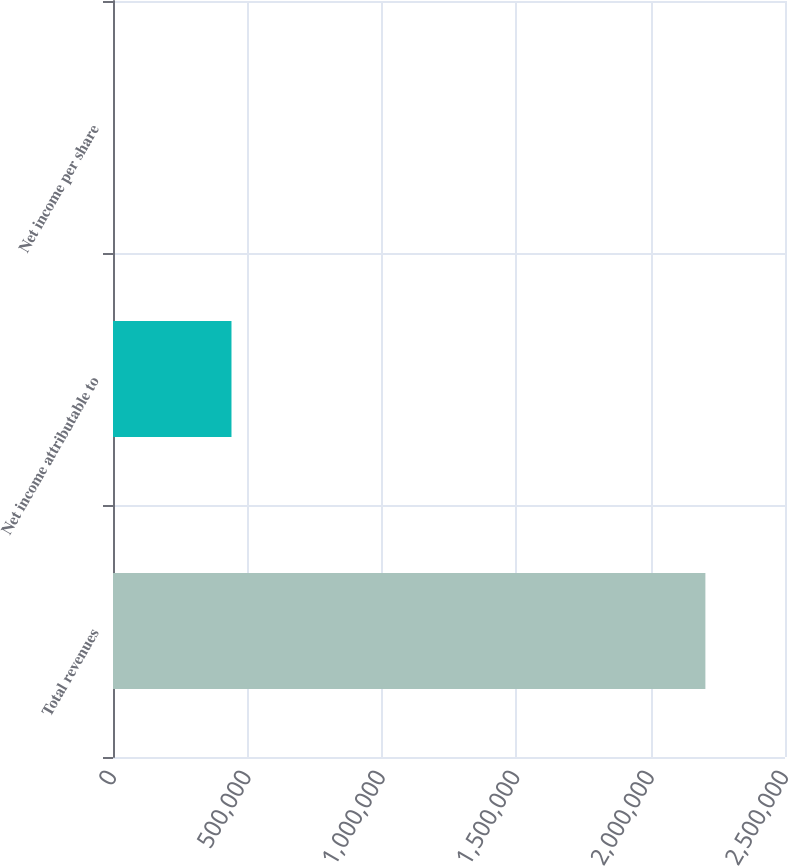Convert chart to OTSL. <chart><loc_0><loc_0><loc_500><loc_500><bar_chart><fcel>Total revenues<fcel>Net income attributable to<fcel>Net income per share<nl><fcel>2.20385e+06<fcel>440771<fcel>2.37<nl></chart> 